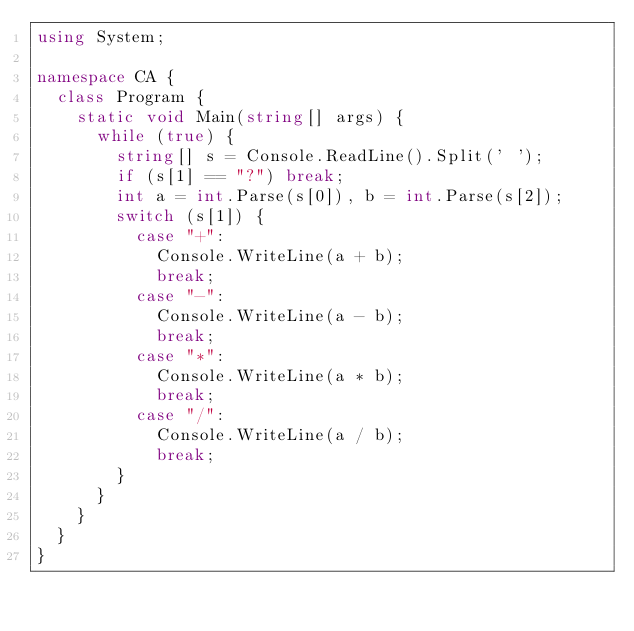Convert code to text. <code><loc_0><loc_0><loc_500><loc_500><_C#_>using System;

namespace CA {
	class Program {
		static void Main(string[] args) {
			while (true) {
				string[] s = Console.ReadLine().Split(' ');
				if (s[1] == "?") break;
				int a = int.Parse(s[0]), b = int.Parse(s[2]);
				switch (s[1]) {
					case "+":
						Console.WriteLine(a + b);
						break;
					case "-":
						Console.WriteLine(a - b);
						break;
					case "*":
						Console.WriteLine(a * b);
						break;
					case "/":
						Console.WriteLine(a / b);
						break;
				}
			}
		}
	}
}</code> 